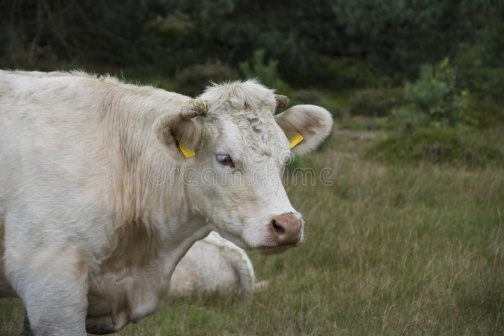What do you see happening in this image? The image captures a tranquil rural setting where a solitary white cow, adorned with yellow ear tags, meanders in a lush green field. This cow, with a gentle expression and relaxed posture, seems to be grazing or simply enjoying the peaceful environment. The backdrop is rich with varied greenery, hinting at an undisturbed natural habitat. Perhaps the cow is part of a small local farm, suggesting a scene of sustainable farming practices. The subtle interplay of light suggests early morning or late afternoon, a time when animals are typically active. This serene snapshot invites viewers to reflect on rural life and the simplicity and beauty of nature. 